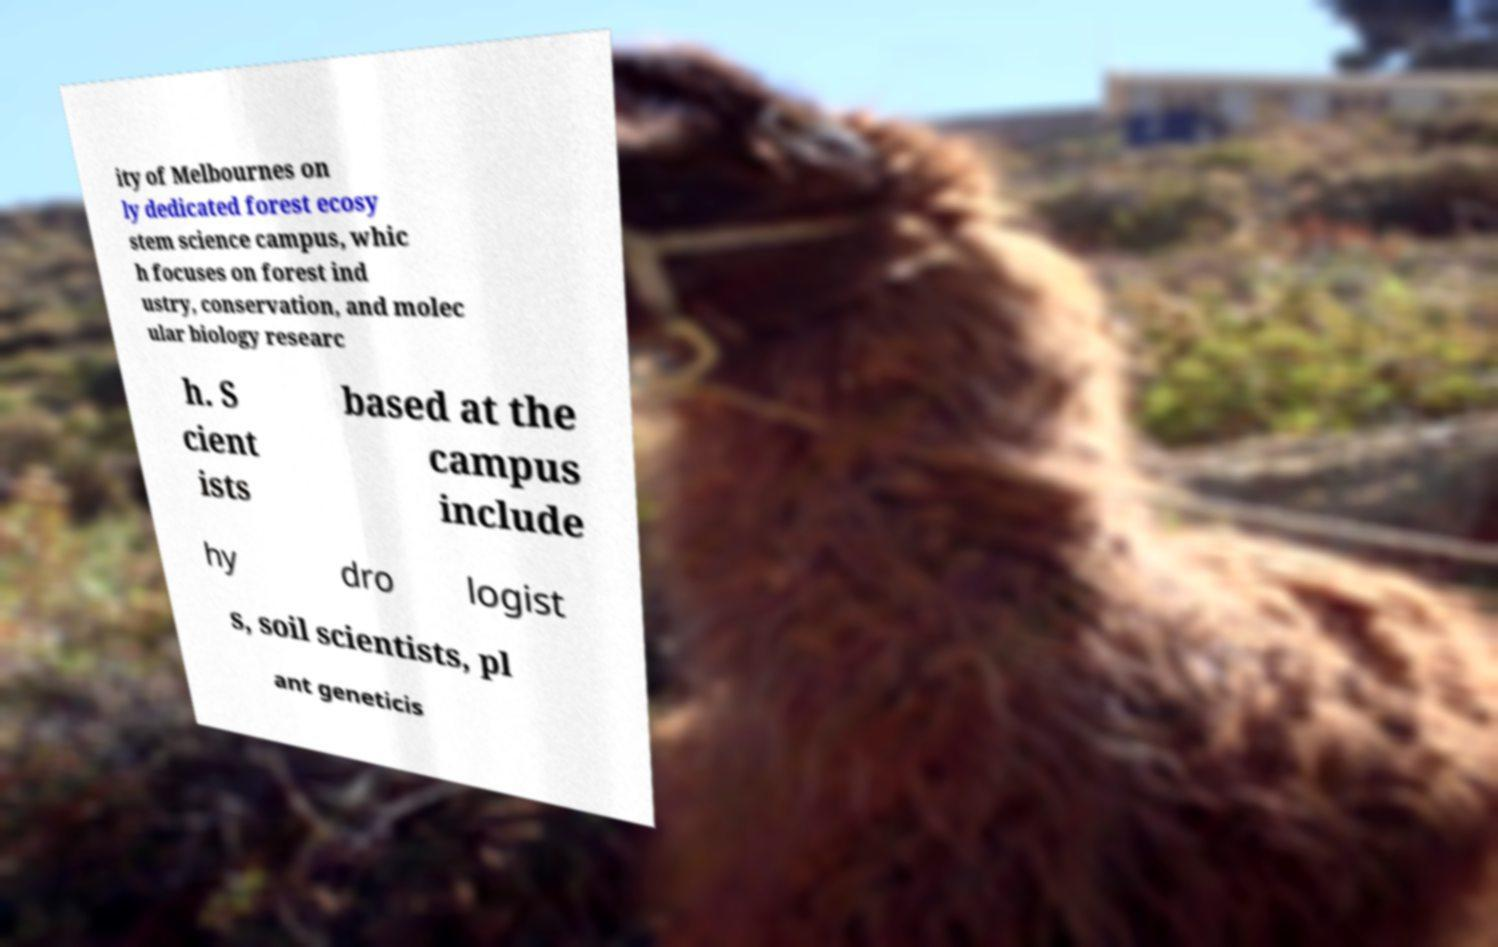What messages or text are displayed in this image? I need them in a readable, typed format. ity of Melbournes on ly dedicated forest ecosy stem science campus, whic h focuses on forest ind ustry, conservation, and molec ular biology researc h. S cient ists based at the campus include hy dro logist s, soil scientists, pl ant geneticis 